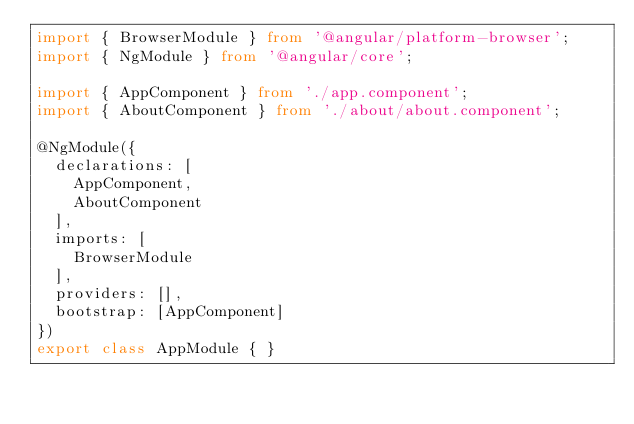<code> <loc_0><loc_0><loc_500><loc_500><_TypeScript_>import { BrowserModule } from '@angular/platform-browser';
import { NgModule } from '@angular/core';

import { AppComponent } from './app.component';
import { AboutComponent } from './about/about.component';

@NgModule({
  declarations: [
    AppComponent,
    AboutComponent
  ],
  imports: [
    BrowserModule
  ],
  providers: [],
  bootstrap: [AppComponent]
})
export class AppModule { }
</code> 